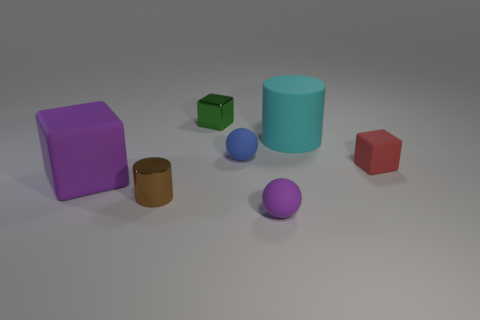Subtract all blue spheres. Subtract all gray cylinders. How many spheres are left? 1 Add 2 metal cylinders. How many objects exist? 9 Subtract all cylinders. How many objects are left? 5 Add 4 tiny purple matte cylinders. How many tiny purple matte cylinders exist? 4 Subtract 1 purple blocks. How many objects are left? 6 Subtract all large purple shiny cubes. Subtract all small purple matte balls. How many objects are left? 6 Add 1 purple blocks. How many purple blocks are left? 2 